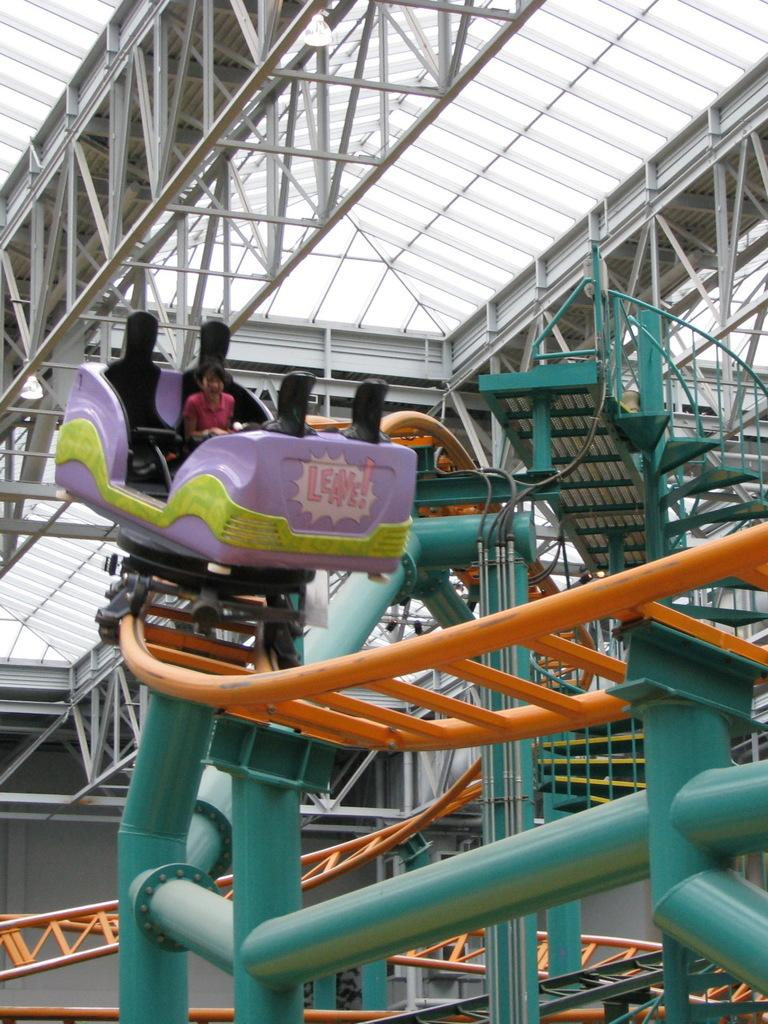Who is present in the image? There is a woman in the image. What is the woman doing in the image? The woman is traveling on electronic instruments. What type of instrument can be seen in the image? There is a metal instrument in the image. What is above the woman in the image? There is a roof in the image. What type of fire can be seen in the image? There is no fire present in the image. What part of the woman's body is made of steel in the image? The woman's body is not made of steel, and there is no part of her body made of steel in the image. 